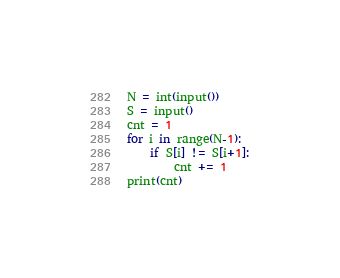<code> <loc_0><loc_0><loc_500><loc_500><_Python_>N = int(input())
S = input()
cnt = 1
for i in range(N-1):
    if S[i] != S[i+1]:
        cnt += 1
print(cnt)</code> 